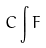<formula> <loc_0><loc_0><loc_500><loc_500>C \int F</formula> 